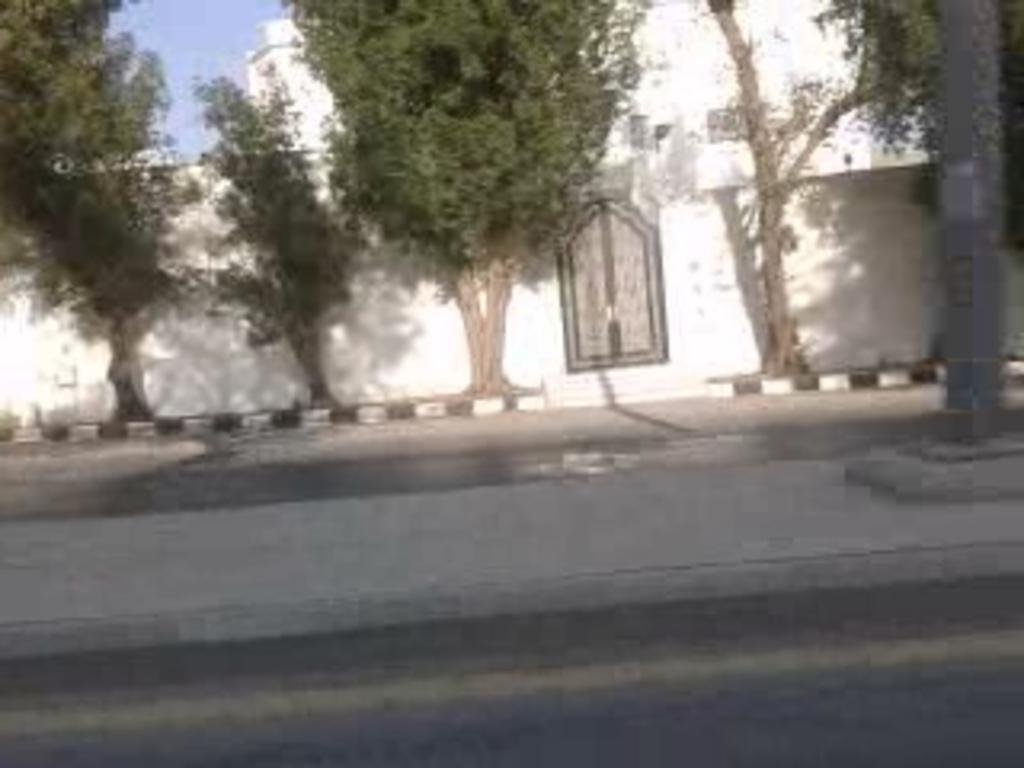In one or two sentences, can you explain what this image depicts? In this picture we can see few trees and buildings, on the right side of the image we can see a pole. 